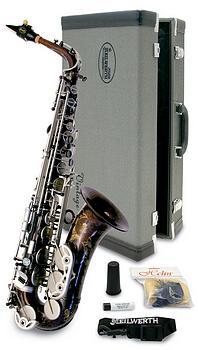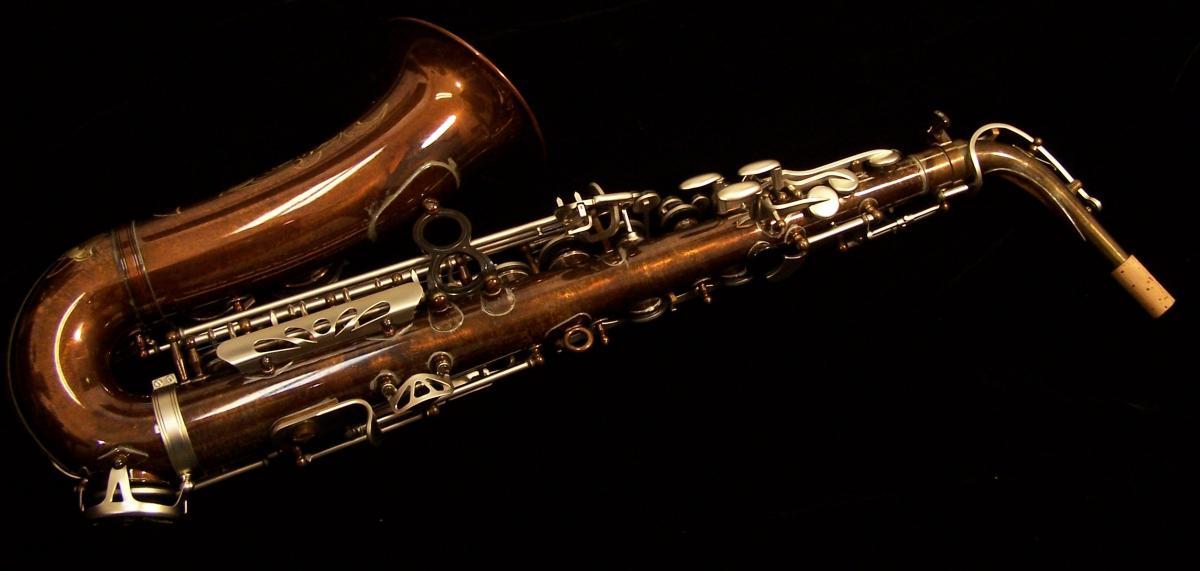The first image is the image on the left, the second image is the image on the right. Considering the images on both sides, is "The saxophone on the right side is on a black background." valid? Answer yes or no. Yes. The first image is the image on the left, the second image is the image on the right. Examine the images to the left and right. Is the description "there are two saxophones and one case in the pair of images." accurate? Answer yes or no. Yes. 